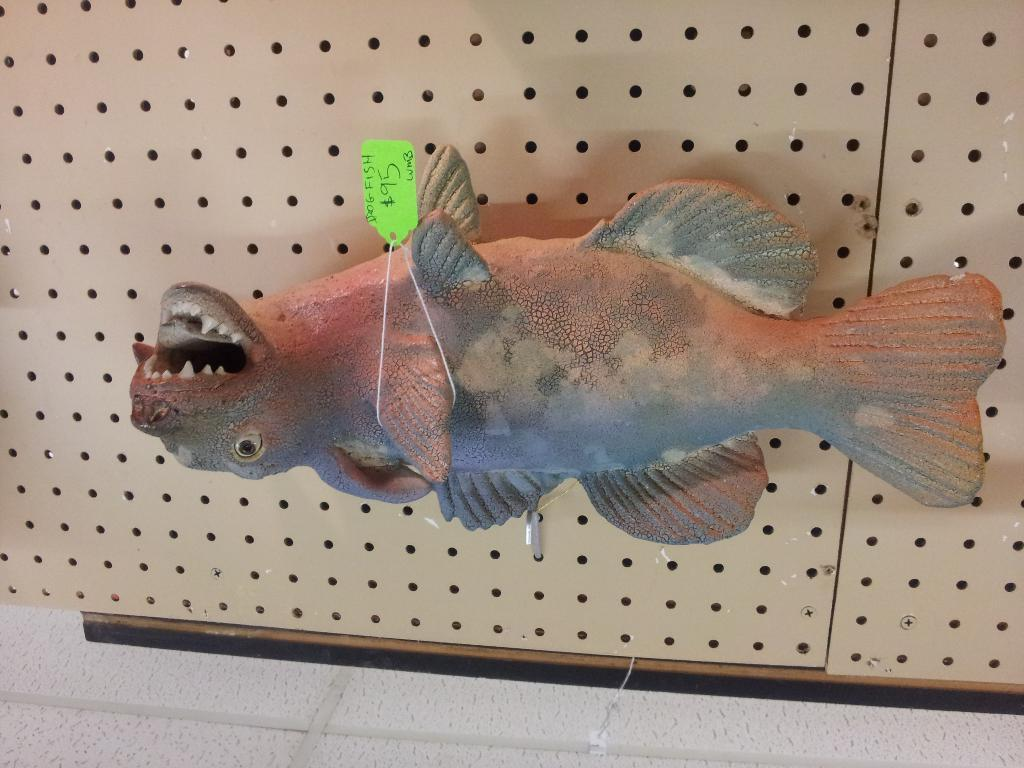What is the main subject in the center of the image? There is a toy fish in the center of the image. What is the toy fish placed on? The toy fish is on a board. What can be seen at the bottom of the image? There is a wall at the bottom of the image. What type of creature is causing pain to the toy fish in the image? There is no creature present in the image, and the toy fish is not experiencing any pain. 